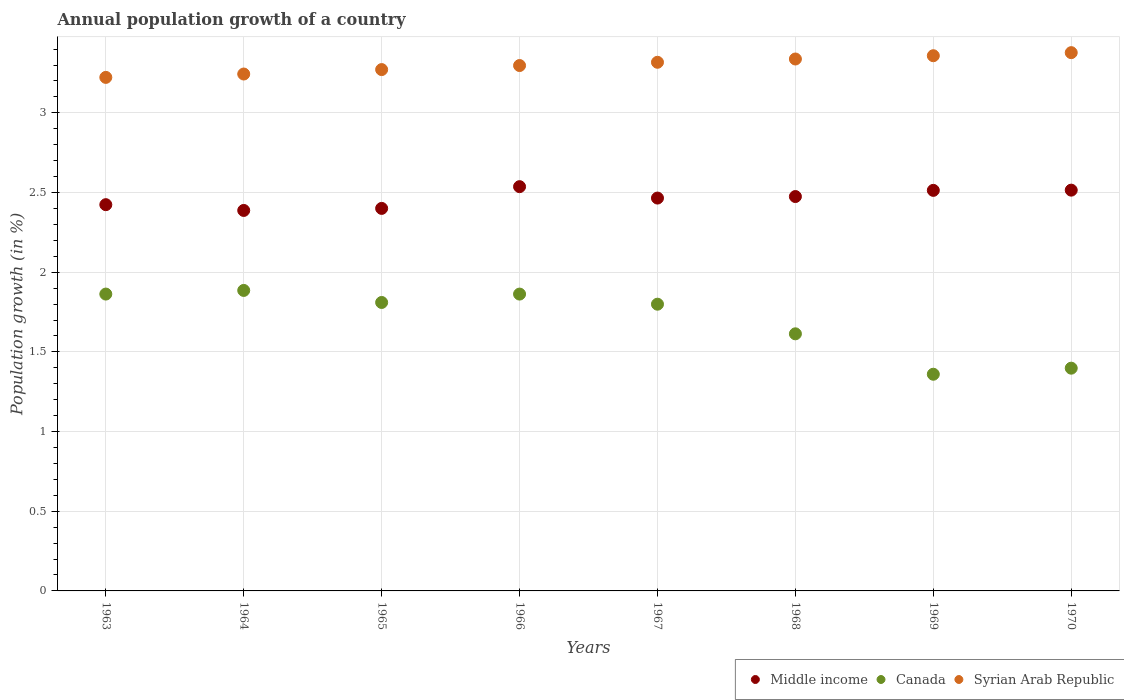How many different coloured dotlines are there?
Give a very brief answer. 3. Is the number of dotlines equal to the number of legend labels?
Offer a very short reply. Yes. What is the annual population growth in Canada in 1966?
Offer a very short reply. 1.86. Across all years, what is the maximum annual population growth in Syrian Arab Republic?
Your response must be concise. 3.38. Across all years, what is the minimum annual population growth in Canada?
Ensure brevity in your answer.  1.36. In which year was the annual population growth in Middle income maximum?
Ensure brevity in your answer.  1966. In which year was the annual population growth in Middle income minimum?
Keep it short and to the point. 1964. What is the total annual population growth in Syrian Arab Republic in the graph?
Ensure brevity in your answer.  26.43. What is the difference between the annual population growth in Middle income in 1964 and that in 1965?
Your answer should be very brief. -0.01. What is the difference between the annual population growth in Syrian Arab Republic in 1967 and the annual population growth in Middle income in 1965?
Provide a short and direct response. 0.92. What is the average annual population growth in Canada per year?
Offer a very short reply. 1.7. In the year 1967, what is the difference between the annual population growth in Canada and annual population growth in Middle income?
Your answer should be very brief. -0.67. In how many years, is the annual population growth in Canada greater than 1.5 %?
Offer a very short reply. 6. What is the ratio of the annual population growth in Middle income in 1968 to that in 1970?
Offer a very short reply. 0.98. Is the difference between the annual population growth in Canada in 1966 and 1968 greater than the difference between the annual population growth in Middle income in 1966 and 1968?
Offer a very short reply. Yes. What is the difference between the highest and the second highest annual population growth in Syrian Arab Republic?
Provide a succinct answer. 0.02. What is the difference between the highest and the lowest annual population growth in Middle income?
Offer a terse response. 0.15. In how many years, is the annual population growth in Canada greater than the average annual population growth in Canada taken over all years?
Provide a succinct answer. 5. Does the annual population growth in Syrian Arab Republic monotonically increase over the years?
Provide a short and direct response. Yes. Is the annual population growth in Middle income strictly less than the annual population growth in Canada over the years?
Make the answer very short. No. How many dotlines are there?
Provide a short and direct response. 3. Are the values on the major ticks of Y-axis written in scientific E-notation?
Your response must be concise. No. Does the graph contain any zero values?
Provide a short and direct response. No. How many legend labels are there?
Your answer should be very brief. 3. How are the legend labels stacked?
Make the answer very short. Horizontal. What is the title of the graph?
Give a very brief answer. Annual population growth of a country. Does "Angola" appear as one of the legend labels in the graph?
Offer a terse response. No. What is the label or title of the Y-axis?
Keep it short and to the point. Population growth (in %). What is the Population growth (in %) of Middle income in 1963?
Offer a terse response. 2.42. What is the Population growth (in %) of Canada in 1963?
Your response must be concise. 1.86. What is the Population growth (in %) in Syrian Arab Republic in 1963?
Offer a very short reply. 3.22. What is the Population growth (in %) of Middle income in 1964?
Keep it short and to the point. 2.39. What is the Population growth (in %) of Canada in 1964?
Offer a very short reply. 1.89. What is the Population growth (in %) in Syrian Arab Republic in 1964?
Offer a very short reply. 3.24. What is the Population growth (in %) in Middle income in 1965?
Make the answer very short. 2.4. What is the Population growth (in %) of Canada in 1965?
Offer a terse response. 1.81. What is the Population growth (in %) in Syrian Arab Republic in 1965?
Provide a succinct answer. 3.27. What is the Population growth (in %) in Middle income in 1966?
Provide a succinct answer. 2.54. What is the Population growth (in %) of Canada in 1966?
Provide a short and direct response. 1.86. What is the Population growth (in %) in Syrian Arab Republic in 1966?
Your answer should be very brief. 3.3. What is the Population growth (in %) of Middle income in 1967?
Provide a short and direct response. 2.47. What is the Population growth (in %) in Canada in 1967?
Give a very brief answer. 1.8. What is the Population growth (in %) in Syrian Arab Republic in 1967?
Your answer should be very brief. 3.32. What is the Population growth (in %) in Middle income in 1968?
Offer a terse response. 2.47. What is the Population growth (in %) of Canada in 1968?
Offer a terse response. 1.61. What is the Population growth (in %) of Syrian Arab Republic in 1968?
Provide a succinct answer. 3.34. What is the Population growth (in %) of Middle income in 1969?
Your answer should be compact. 2.51. What is the Population growth (in %) of Canada in 1969?
Your answer should be very brief. 1.36. What is the Population growth (in %) of Syrian Arab Republic in 1969?
Offer a very short reply. 3.36. What is the Population growth (in %) in Middle income in 1970?
Offer a terse response. 2.52. What is the Population growth (in %) in Canada in 1970?
Keep it short and to the point. 1.4. What is the Population growth (in %) in Syrian Arab Republic in 1970?
Your answer should be very brief. 3.38. Across all years, what is the maximum Population growth (in %) in Middle income?
Your answer should be very brief. 2.54. Across all years, what is the maximum Population growth (in %) of Canada?
Give a very brief answer. 1.89. Across all years, what is the maximum Population growth (in %) in Syrian Arab Republic?
Provide a succinct answer. 3.38. Across all years, what is the minimum Population growth (in %) in Middle income?
Your answer should be very brief. 2.39. Across all years, what is the minimum Population growth (in %) of Canada?
Offer a very short reply. 1.36. Across all years, what is the minimum Population growth (in %) of Syrian Arab Republic?
Your response must be concise. 3.22. What is the total Population growth (in %) in Middle income in the graph?
Your answer should be compact. 19.72. What is the total Population growth (in %) in Canada in the graph?
Offer a very short reply. 13.59. What is the total Population growth (in %) in Syrian Arab Republic in the graph?
Make the answer very short. 26.43. What is the difference between the Population growth (in %) in Middle income in 1963 and that in 1964?
Your answer should be compact. 0.04. What is the difference between the Population growth (in %) in Canada in 1963 and that in 1964?
Keep it short and to the point. -0.02. What is the difference between the Population growth (in %) in Syrian Arab Republic in 1963 and that in 1964?
Provide a short and direct response. -0.02. What is the difference between the Population growth (in %) of Middle income in 1963 and that in 1965?
Keep it short and to the point. 0.02. What is the difference between the Population growth (in %) in Canada in 1963 and that in 1965?
Your response must be concise. 0.05. What is the difference between the Population growth (in %) in Syrian Arab Republic in 1963 and that in 1965?
Your response must be concise. -0.05. What is the difference between the Population growth (in %) in Middle income in 1963 and that in 1966?
Give a very brief answer. -0.11. What is the difference between the Population growth (in %) of Canada in 1963 and that in 1966?
Offer a very short reply. 0. What is the difference between the Population growth (in %) in Syrian Arab Republic in 1963 and that in 1966?
Your answer should be very brief. -0.07. What is the difference between the Population growth (in %) of Middle income in 1963 and that in 1967?
Offer a terse response. -0.04. What is the difference between the Population growth (in %) in Canada in 1963 and that in 1967?
Provide a succinct answer. 0.06. What is the difference between the Population growth (in %) of Syrian Arab Republic in 1963 and that in 1967?
Offer a terse response. -0.09. What is the difference between the Population growth (in %) in Middle income in 1963 and that in 1968?
Your answer should be compact. -0.05. What is the difference between the Population growth (in %) in Canada in 1963 and that in 1968?
Your answer should be compact. 0.25. What is the difference between the Population growth (in %) of Syrian Arab Republic in 1963 and that in 1968?
Offer a terse response. -0.12. What is the difference between the Population growth (in %) in Middle income in 1963 and that in 1969?
Keep it short and to the point. -0.09. What is the difference between the Population growth (in %) of Canada in 1963 and that in 1969?
Your answer should be compact. 0.5. What is the difference between the Population growth (in %) in Syrian Arab Republic in 1963 and that in 1969?
Provide a succinct answer. -0.14. What is the difference between the Population growth (in %) in Middle income in 1963 and that in 1970?
Your answer should be very brief. -0.09. What is the difference between the Population growth (in %) of Canada in 1963 and that in 1970?
Give a very brief answer. 0.47. What is the difference between the Population growth (in %) in Syrian Arab Republic in 1963 and that in 1970?
Ensure brevity in your answer.  -0.16. What is the difference between the Population growth (in %) in Middle income in 1964 and that in 1965?
Offer a very short reply. -0.01. What is the difference between the Population growth (in %) in Canada in 1964 and that in 1965?
Your response must be concise. 0.08. What is the difference between the Population growth (in %) in Syrian Arab Republic in 1964 and that in 1965?
Keep it short and to the point. -0.03. What is the difference between the Population growth (in %) in Middle income in 1964 and that in 1966?
Your answer should be very brief. -0.15. What is the difference between the Population growth (in %) in Canada in 1964 and that in 1966?
Provide a short and direct response. 0.02. What is the difference between the Population growth (in %) of Syrian Arab Republic in 1964 and that in 1966?
Provide a succinct answer. -0.05. What is the difference between the Population growth (in %) of Middle income in 1964 and that in 1967?
Ensure brevity in your answer.  -0.08. What is the difference between the Population growth (in %) in Canada in 1964 and that in 1967?
Provide a short and direct response. 0.09. What is the difference between the Population growth (in %) in Syrian Arab Republic in 1964 and that in 1967?
Offer a terse response. -0.07. What is the difference between the Population growth (in %) in Middle income in 1964 and that in 1968?
Provide a short and direct response. -0.09. What is the difference between the Population growth (in %) in Canada in 1964 and that in 1968?
Keep it short and to the point. 0.27. What is the difference between the Population growth (in %) in Syrian Arab Republic in 1964 and that in 1968?
Give a very brief answer. -0.09. What is the difference between the Population growth (in %) of Middle income in 1964 and that in 1969?
Your answer should be very brief. -0.13. What is the difference between the Population growth (in %) in Canada in 1964 and that in 1969?
Give a very brief answer. 0.53. What is the difference between the Population growth (in %) of Syrian Arab Republic in 1964 and that in 1969?
Your answer should be very brief. -0.11. What is the difference between the Population growth (in %) of Middle income in 1964 and that in 1970?
Your answer should be very brief. -0.13. What is the difference between the Population growth (in %) of Canada in 1964 and that in 1970?
Keep it short and to the point. 0.49. What is the difference between the Population growth (in %) of Syrian Arab Republic in 1964 and that in 1970?
Offer a terse response. -0.13. What is the difference between the Population growth (in %) of Middle income in 1965 and that in 1966?
Your answer should be very brief. -0.14. What is the difference between the Population growth (in %) of Canada in 1965 and that in 1966?
Your response must be concise. -0.05. What is the difference between the Population growth (in %) in Syrian Arab Republic in 1965 and that in 1966?
Your answer should be very brief. -0.03. What is the difference between the Population growth (in %) in Middle income in 1965 and that in 1967?
Your answer should be compact. -0.06. What is the difference between the Population growth (in %) of Canada in 1965 and that in 1967?
Offer a terse response. 0.01. What is the difference between the Population growth (in %) of Syrian Arab Republic in 1965 and that in 1967?
Give a very brief answer. -0.05. What is the difference between the Population growth (in %) of Middle income in 1965 and that in 1968?
Give a very brief answer. -0.07. What is the difference between the Population growth (in %) of Canada in 1965 and that in 1968?
Offer a terse response. 0.2. What is the difference between the Population growth (in %) of Syrian Arab Republic in 1965 and that in 1968?
Make the answer very short. -0.07. What is the difference between the Population growth (in %) of Middle income in 1965 and that in 1969?
Make the answer very short. -0.11. What is the difference between the Population growth (in %) in Canada in 1965 and that in 1969?
Provide a succinct answer. 0.45. What is the difference between the Population growth (in %) of Syrian Arab Republic in 1965 and that in 1969?
Your response must be concise. -0.09. What is the difference between the Population growth (in %) in Middle income in 1965 and that in 1970?
Offer a very short reply. -0.11. What is the difference between the Population growth (in %) in Canada in 1965 and that in 1970?
Your answer should be very brief. 0.41. What is the difference between the Population growth (in %) in Syrian Arab Republic in 1965 and that in 1970?
Ensure brevity in your answer.  -0.11. What is the difference between the Population growth (in %) of Middle income in 1966 and that in 1967?
Your answer should be very brief. 0.07. What is the difference between the Population growth (in %) in Canada in 1966 and that in 1967?
Your response must be concise. 0.06. What is the difference between the Population growth (in %) of Syrian Arab Republic in 1966 and that in 1967?
Keep it short and to the point. -0.02. What is the difference between the Population growth (in %) in Middle income in 1966 and that in 1968?
Your answer should be very brief. 0.06. What is the difference between the Population growth (in %) of Canada in 1966 and that in 1968?
Offer a terse response. 0.25. What is the difference between the Population growth (in %) in Syrian Arab Republic in 1966 and that in 1968?
Give a very brief answer. -0.04. What is the difference between the Population growth (in %) of Middle income in 1966 and that in 1969?
Provide a short and direct response. 0.02. What is the difference between the Population growth (in %) of Canada in 1966 and that in 1969?
Keep it short and to the point. 0.5. What is the difference between the Population growth (in %) in Syrian Arab Republic in 1966 and that in 1969?
Provide a succinct answer. -0.06. What is the difference between the Population growth (in %) of Middle income in 1966 and that in 1970?
Provide a short and direct response. 0.02. What is the difference between the Population growth (in %) in Canada in 1966 and that in 1970?
Give a very brief answer. 0.47. What is the difference between the Population growth (in %) in Syrian Arab Republic in 1966 and that in 1970?
Your answer should be compact. -0.08. What is the difference between the Population growth (in %) in Middle income in 1967 and that in 1968?
Make the answer very short. -0.01. What is the difference between the Population growth (in %) in Canada in 1967 and that in 1968?
Provide a short and direct response. 0.19. What is the difference between the Population growth (in %) in Syrian Arab Republic in 1967 and that in 1968?
Offer a terse response. -0.02. What is the difference between the Population growth (in %) in Middle income in 1967 and that in 1969?
Ensure brevity in your answer.  -0.05. What is the difference between the Population growth (in %) of Canada in 1967 and that in 1969?
Ensure brevity in your answer.  0.44. What is the difference between the Population growth (in %) of Syrian Arab Republic in 1967 and that in 1969?
Keep it short and to the point. -0.04. What is the difference between the Population growth (in %) of Middle income in 1967 and that in 1970?
Ensure brevity in your answer.  -0.05. What is the difference between the Population growth (in %) in Canada in 1967 and that in 1970?
Provide a short and direct response. 0.4. What is the difference between the Population growth (in %) in Syrian Arab Republic in 1967 and that in 1970?
Your answer should be very brief. -0.06. What is the difference between the Population growth (in %) in Middle income in 1968 and that in 1969?
Provide a short and direct response. -0.04. What is the difference between the Population growth (in %) of Canada in 1968 and that in 1969?
Ensure brevity in your answer.  0.25. What is the difference between the Population growth (in %) of Syrian Arab Republic in 1968 and that in 1969?
Your response must be concise. -0.02. What is the difference between the Population growth (in %) in Middle income in 1968 and that in 1970?
Give a very brief answer. -0.04. What is the difference between the Population growth (in %) in Canada in 1968 and that in 1970?
Provide a succinct answer. 0.22. What is the difference between the Population growth (in %) in Syrian Arab Republic in 1968 and that in 1970?
Offer a very short reply. -0.04. What is the difference between the Population growth (in %) of Middle income in 1969 and that in 1970?
Ensure brevity in your answer.  -0. What is the difference between the Population growth (in %) in Canada in 1969 and that in 1970?
Offer a very short reply. -0.04. What is the difference between the Population growth (in %) of Syrian Arab Republic in 1969 and that in 1970?
Give a very brief answer. -0.02. What is the difference between the Population growth (in %) of Middle income in 1963 and the Population growth (in %) of Canada in 1964?
Ensure brevity in your answer.  0.54. What is the difference between the Population growth (in %) in Middle income in 1963 and the Population growth (in %) in Syrian Arab Republic in 1964?
Provide a succinct answer. -0.82. What is the difference between the Population growth (in %) in Canada in 1963 and the Population growth (in %) in Syrian Arab Republic in 1964?
Make the answer very short. -1.38. What is the difference between the Population growth (in %) in Middle income in 1963 and the Population growth (in %) in Canada in 1965?
Your answer should be very brief. 0.61. What is the difference between the Population growth (in %) in Middle income in 1963 and the Population growth (in %) in Syrian Arab Republic in 1965?
Keep it short and to the point. -0.85. What is the difference between the Population growth (in %) of Canada in 1963 and the Population growth (in %) of Syrian Arab Republic in 1965?
Offer a terse response. -1.41. What is the difference between the Population growth (in %) in Middle income in 1963 and the Population growth (in %) in Canada in 1966?
Your response must be concise. 0.56. What is the difference between the Population growth (in %) in Middle income in 1963 and the Population growth (in %) in Syrian Arab Republic in 1966?
Your answer should be compact. -0.87. What is the difference between the Population growth (in %) of Canada in 1963 and the Population growth (in %) of Syrian Arab Republic in 1966?
Provide a short and direct response. -1.43. What is the difference between the Population growth (in %) in Middle income in 1963 and the Population growth (in %) in Canada in 1967?
Your answer should be very brief. 0.62. What is the difference between the Population growth (in %) in Middle income in 1963 and the Population growth (in %) in Syrian Arab Republic in 1967?
Offer a terse response. -0.89. What is the difference between the Population growth (in %) of Canada in 1963 and the Population growth (in %) of Syrian Arab Republic in 1967?
Provide a short and direct response. -1.45. What is the difference between the Population growth (in %) in Middle income in 1963 and the Population growth (in %) in Canada in 1968?
Give a very brief answer. 0.81. What is the difference between the Population growth (in %) of Middle income in 1963 and the Population growth (in %) of Syrian Arab Republic in 1968?
Offer a terse response. -0.91. What is the difference between the Population growth (in %) of Canada in 1963 and the Population growth (in %) of Syrian Arab Republic in 1968?
Provide a succinct answer. -1.48. What is the difference between the Population growth (in %) of Middle income in 1963 and the Population growth (in %) of Canada in 1969?
Your answer should be very brief. 1.06. What is the difference between the Population growth (in %) of Middle income in 1963 and the Population growth (in %) of Syrian Arab Republic in 1969?
Your answer should be very brief. -0.93. What is the difference between the Population growth (in %) of Canada in 1963 and the Population growth (in %) of Syrian Arab Republic in 1969?
Make the answer very short. -1.5. What is the difference between the Population growth (in %) in Middle income in 1963 and the Population growth (in %) in Canada in 1970?
Your response must be concise. 1.03. What is the difference between the Population growth (in %) in Middle income in 1963 and the Population growth (in %) in Syrian Arab Republic in 1970?
Keep it short and to the point. -0.95. What is the difference between the Population growth (in %) in Canada in 1963 and the Population growth (in %) in Syrian Arab Republic in 1970?
Keep it short and to the point. -1.51. What is the difference between the Population growth (in %) in Middle income in 1964 and the Population growth (in %) in Canada in 1965?
Your response must be concise. 0.58. What is the difference between the Population growth (in %) in Middle income in 1964 and the Population growth (in %) in Syrian Arab Republic in 1965?
Offer a very short reply. -0.88. What is the difference between the Population growth (in %) in Canada in 1964 and the Population growth (in %) in Syrian Arab Republic in 1965?
Offer a very short reply. -1.39. What is the difference between the Population growth (in %) in Middle income in 1964 and the Population growth (in %) in Canada in 1966?
Provide a succinct answer. 0.52. What is the difference between the Population growth (in %) in Middle income in 1964 and the Population growth (in %) in Syrian Arab Republic in 1966?
Your answer should be compact. -0.91. What is the difference between the Population growth (in %) of Canada in 1964 and the Population growth (in %) of Syrian Arab Republic in 1966?
Offer a terse response. -1.41. What is the difference between the Population growth (in %) in Middle income in 1964 and the Population growth (in %) in Canada in 1967?
Keep it short and to the point. 0.59. What is the difference between the Population growth (in %) in Middle income in 1964 and the Population growth (in %) in Syrian Arab Republic in 1967?
Keep it short and to the point. -0.93. What is the difference between the Population growth (in %) in Canada in 1964 and the Population growth (in %) in Syrian Arab Republic in 1967?
Provide a short and direct response. -1.43. What is the difference between the Population growth (in %) in Middle income in 1964 and the Population growth (in %) in Canada in 1968?
Ensure brevity in your answer.  0.77. What is the difference between the Population growth (in %) in Middle income in 1964 and the Population growth (in %) in Syrian Arab Republic in 1968?
Make the answer very short. -0.95. What is the difference between the Population growth (in %) of Canada in 1964 and the Population growth (in %) of Syrian Arab Republic in 1968?
Provide a short and direct response. -1.45. What is the difference between the Population growth (in %) of Middle income in 1964 and the Population growth (in %) of Canada in 1969?
Offer a very short reply. 1.03. What is the difference between the Population growth (in %) of Middle income in 1964 and the Population growth (in %) of Syrian Arab Republic in 1969?
Your answer should be compact. -0.97. What is the difference between the Population growth (in %) in Canada in 1964 and the Population growth (in %) in Syrian Arab Republic in 1969?
Your answer should be compact. -1.47. What is the difference between the Population growth (in %) of Middle income in 1964 and the Population growth (in %) of Canada in 1970?
Your answer should be compact. 0.99. What is the difference between the Population growth (in %) of Middle income in 1964 and the Population growth (in %) of Syrian Arab Republic in 1970?
Offer a very short reply. -0.99. What is the difference between the Population growth (in %) of Canada in 1964 and the Population growth (in %) of Syrian Arab Republic in 1970?
Ensure brevity in your answer.  -1.49. What is the difference between the Population growth (in %) in Middle income in 1965 and the Population growth (in %) in Canada in 1966?
Offer a terse response. 0.54. What is the difference between the Population growth (in %) in Middle income in 1965 and the Population growth (in %) in Syrian Arab Republic in 1966?
Your response must be concise. -0.9. What is the difference between the Population growth (in %) in Canada in 1965 and the Population growth (in %) in Syrian Arab Republic in 1966?
Ensure brevity in your answer.  -1.49. What is the difference between the Population growth (in %) in Middle income in 1965 and the Population growth (in %) in Canada in 1967?
Provide a succinct answer. 0.6. What is the difference between the Population growth (in %) of Middle income in 1965 and the Population growth (in %) of Syrian Arab Republic in 1967?
Ensure brevity in your answer.  -0.92. What is the difference between the Population growth (in %) in Canada in 1965 and the Population growth (in %) in Syrian Arab Republic in 1967?
Your answer should be very brief. -1.51. What is the difference between the Population growth (in %) of Middle income in 1965 and the Population growth (in %) of Canada in 1968?
Your answer should be very brief. 0.79. What is the difference between the Population growth (in %) of Middle income in 1965 and the Population growth (in %) of Syrian Arab Republic in 1968?
Give a very brief answer. -0.94. What is the difference between the Population growth (in %) of Canada in 1965 and the Population growth (in %) of Syrian Arab Republic in 1968?
Your answer should be compact. -1.53. What is the difference between the Population growth (in %) of Middle income in 1965 and the Population growth (in %) of Canada in 1969?
Ensure brevity in your answer.  1.04. What is the difference between the Population growth (in %) of Middle income in 1965 and the Population growth (in %) of Syrian Arab Republic in 1969?
Keep it short and to the point. -0.96. What is the difference between the Population growth (in %) of Canada in 1965 and the Population growth (in %) of Syrian Arab Republic in 1969?
Ensure brevity in your answer.  -1.55. What is the difference between the Population growth (in %) of Middle income in 1965 and the Population growth (in %) of Canada in 1970?
Offer a terse response. 1. What is the difference between the Population growth (in %) of Middle income in 1965 and the Population growth (in %) of Syrian Arab Republic in 1970?
Your answer should be very brief. -0.98. What is the difference between the Population growth (in %) of Canada in 1965 and the Population growth (in %) of Syrian Arab Republic in 1970?
Provide a short and direct response. -1.57. What is the difference between the Population growth (in %) in Middle income in 1966 and the Population growth (in %) in Canada in 1967?
Your response must be concise. 0.74. What is the difference between the Population growth (in %) of Middle income in 1966 and the Population growth (in %) of Syrian Arab Republic in 1967?
Keep it short and to the point. -0.78. What is the difference between the Population growth (in %) of Canada in 1966 and the Population growth (in %) of Syrian Arab Republic in 1967?
Provide a succinct answer. -1.45. What is the difference between the Population growth (in %) in Middle income in 1966 and the Population growth (in %) in Canada in 1968?
Ensure brevity in your answer.  0.92. What is the difference between the Population growth (in %) of Middle income in 1966 and the Population growth (in %) of Syrian Arab Republic in 1968?
Offer a very short reply. -0.8. What is the difference between the Population growth (in %) in Canada in 1966 and the Population growth (in %) in Syrian Arab Republic in 1968?
Your answer should be compact. -1.48. What is the difference between the Population growth (in %) of Middle income in 1966 and the Population growth (in %) of Canada in 1969?
Your response must be concise. 1.18. What is the difference between the Population growth (in %) of Middle income in 1966 and the Population growth (in %) of Syrian Arab Republic in 1969?
Your answer should be compact. -0.82. What is the difference between the Population growth (in %) of Canada in 1966 and the Population growth (in %) of Syrian Arab Republic in 1969?
Your response must be concise. -1.5. What is the difference between the Population growth (in %) in Middle income in 1966 and the Population growth (in %) in Canada in 1970?
Your response must be concise. 1.14. What is the difference between the Population growth (in %) of Middle income in 1966 and the Population growth (in %) of Syrian Arab Republic in 1970?
Your answer should be compact. -0.84. What is the difference between the Population growth (in %) in Canada in 1966 and the Population growth (in %) in Syrian Arab Republic in 1970?
Your answer should be very brief. -1.52. What is the difference between the Population growth (in %) of Middle income in 1967 and the Population growth (in %) of Canada in 1968?
Keep it short and to the point. 0.85. What is the difference between the Population growth (in %) in Middle income in 1967 and the Population growth (in %) in Syrian Arab Republic in 1968?
Give a very brief answer. -0.87. What is the difference between the Population growth (in %) in Canada in 1967 and the Population growth (in %) in Syrian Arab Republic in 1968?
Offer a terse response. -1.54. What is the difference between the Population growth (in %) in Middle income in 1967 and the Population growth (in %) in Canada in 1969?
Make the answer very short. 1.11. What is the difference between the Population growth (in %) in Middle income in 1967 and the Population growth (in %) in Syrian Arab Republic in 1969?
Offer a very short reply. -0.89. What is the difference between the Population growth (in %) of Canada in 1967 and the Population growth (in %) of Syrian Arab Republic in 1969?
Your answer should be compact. -1.56. What is the difference between the Population growth (in %) in Middle income in 1967 and the Population growth (in %) in Canada in 1970?
Ensure brevity in your answer.  1.07. What is the difference between the Population growth (in %) in Middle income in 1967 and the Population growth (in %) in Syrian Arab Republic in 1970?
Your answer should be compact. -0.91. What is the difference between the Population growth (in %) in Canada in 1967 and the Population growth (in %) in Syrian Arab Republic in 1970?
Keep it short and to the point. -1.58. What is the difference between the Population growth (in %) in Middle income in 1968 and the Population growth (in %) in Canada in 1969?
Your answer should be very brief. 1.12. What is the difference between the Population growth (in %) of Middle income in 1968 and the Population growth (in %) of Syrian Arab Republic in 1969?
Offer a very short reply. -0.88. What is the difference between the Population growth (in %) in Canada in 1968 and the Population growth (in %) in Syrian Arab Republic in 1969?
Offer a terse response. -1.75. What is the difference between the Population growth (in %) in Middle income in 1968 and the Population growth (in %) in Canada in 1970?
Keep it short and to the point. 1.08. What is the difference between the Population growth (in %) in Middle income in 1968 and the Population growth (in %) in Syrian Arab Republic in 1970?
Keep it short and to the point. -0.9. What is the difference between the Population growth (in %) of Canada in 1968 and the Population growth (in %) of Syrian Arab Republic in 1970?
Your answer should be compact. -1.76. What is the difference between the Population growth (in %) of Middle income in 1969 and the Population growth (in %) of Canada in 1970?
Provide a succinct answer. 1.12. What is the difference between the Population growth (in %) of Middle income in 1969 and the Population growth (in %) of Syrian Arab Republic in 1970?
Give a very brief answer. -0.86. What is the difference between the Population growth (in %) of Canada in 1969 and the Population growth (in %) of Syrian Arab Republic in 1970?
Keep it short and to the point. -2.02. What is the average Population growth (in %) of Middle income per year?
Your response must be concise. 2.46. What is the average Population growth (in %) of Canada per year?
Your answer should be compact. 1.7. What is the average Population growth (in %) in Syrian Arab Republic per year?
Keep it short and to the point. 3.3. In the year 1963, what is the difference between the Population growth (in %) in Middle income and Population growth (in %) in Canada?
Ensure brevity in your answer.  0.56. In the year 1963, what is the difference between the Population growth (in %) of Middle income and Population growth (in %) of Syrian Arab Republic?
Offer a very short reply. -0.8. In the year 1963, what is the difference between the Population growth (in %) in Canada and Population growth (in %) in Syrian Arab Republic?
Your answer should be compact. -1.36. In the year 1964, what is the difference between the Population growth (in %) of Middle income and Population growth (in %) of Canada?
Make the answer very short. 0.5. In the year 1964, what is the difference between the Population growth (in %) of Middle income and Population growth (in %) of Syrian Arab Republic?
Ensure brevity in your answer.  -0.86. In the year 1964, what is the difference between the Population growth (in %) in Canada and Population growth (in %) in Syrian Arab Republic?
Keep it short and to the point. -1.36. In the year 1965, what is the difference between the Population growth (in %) in Middle income and Population growth (in %) in Canada?
Your answer should be very brief. 0.59. In the year 1965, what is the difference between the Population growth (in %) of Middle income and Population growth (in %) of Syrian Arab Republic?
Keep it short and to the point. -0.87. In the year 1965, what is the difference between the Population growth (in %) of Canada and Population growth (in %) of Syrian Arab Republic?
Ensure brevity in your answer.  -1.46. In the year 1966, what is the difference between the Population growth (in %) of Middle income and Population growth (in %) of Canada?
Provide a succinct answer. 0.67. In the year 1966, what is the difference between the Population growth (in %) in Middle income and Population growth (in %) in Syrian Arab Republic?
Provide a short and direct response. -0.76. In the year 1966, what is the difference between the Population growth (in %) of Canada and Population growth (in %) of Syrian Arab Republic?
Your response must be concise. -1.43. In the year 1967, what is the difference between the Population growth (in %) of Middle income and Population growth (in %) of Canada?
Your answer should be very brief. 0.67. In the year 1967, what is the difference between the Population growth (in %) of Middle income and Population growth (in %) of Syrian Arab Republic?
Offer a terse response. -0.85. In the year 1967, what is the difference between the Population growth (in %) in Canada and Population growth (in %) in Syrian Arab Republic?
Offer a terse response. -1.52. In the year 1968, what is the difference between the Population growth (in %) in Middle income and Population growth (in %) in Canada?
Your answer should be compact. 0.86. In the year 1968, what is the difference between the Population growth (in %) in Middle income and Population growth (in %) in Syrian Arab Republic?
Offer a very short reply. -0.86. In the year 1968, what is the difference between the Population growth (in %) in Canada and Population growth (in %) in Syrian Arab Republic?
Offer a very short reply. -1.72. In the year 1969, what is the difference between the Population growth (in %) in Middle income and Population growth (in %) in Canada?
Keep it short and to the point. 1.15. In the year 1969, what is the difference between the Population growth (in %) in Middle income and Population growth (in %) in Syrian Arab Republic?
Your response must be concise. -0.84. In the year 1969, what is the difference between the Population growth (in %) in Canada and Population growth (in %) in Syrian Arab Republic?
Offer a very short reply. -2. In the year 1970, what is the difference between the Population growth (in %) of Middle income and Population growth (in %) of Canada?
Your answer should be compact. 1.12. In the year 1970, what is the difference between the Population growth (in %) of Middle income and Population growth (in %) of Syrian Arab Republic?
Make the answer very short. -0.86. In the year 1970, what is the difference between the Population growth (in %) of Canada and Population growth (in %) of Syrian Arab Republic?
Give a very brief answer. -1.98. What is the ratio of the Population growth (in %) in Middle income in 1963 to that in 1964?
Make the answer very short. 1.02. What is the ratio of the Population growth (in %) in Canada in 1963 to that in 1964?
Keep it short and to the point. 0.99. What is the ratio of the Population growth (in %) in Middle income in 1963 to that in 1965?
Make the answer very short. 1.01. What is the ratio of the Population growth (in %) of Canada in 1963 to that in 1965?
Ensure brevity in your answer.  1.03. What is the ratio of the Population growth (in %) in Middle income in 1963 to that in 1966?
Ensure brevity in your answer.  0.96. What is the ratio of the Population growth (in %) in Canada in 1963 to that in 1966?
Ensure brevity in your answer.  1. What is the ratio of the Population growth (in %) of Syrian Arab Republic in 1963 to that in 1966?
Offer a very short reply. 0.98. What is the ratio of the Population growth (in %) in Middle income in 1963 to that in 1967?
Keep it short and to the point. 0.98. What is the ratio of the Population growth (in %) in Canada in 1963 to that in 1967?
Offer a very short reply. 1.04. What is the ratio of the Population growth (in %) of Syrian Arab Republic in 1963 to that in 1967?
Offer a very short reply. 0.97. What is the ratio of the Population growth (in %) of Middle income in 1963 to that in 1968?
Your response must be concise. 0.98. What is the ratio of the Population growth (in %) in Canada in 1963 to that in 1968?
Make the answer very short. 1.15. What is the ratio of the Population growth (in %) of Syrian Arab Republic in 1963 to that in 1968?
Keep it short and to the point. 0.97. What is the ratio of the Population growth (in %) of Canada in 1963 to that in 1969?
Your response must be concise. 1.37. What is the ratio of the Population growth (in %) in Syrian Arab Republic in 1963 to that in 1969?
Your answer should be compact. 0.96. What is the ratio of the Population growth (in %) in Middle income in 1963 to that in 1970?
Give a very brief answer. 0.96. What is the ratio of the Population growth (in %) in Canada in 1963 to that in 1970?
Offer a terse response. 1.33. What is the ratio of the Population growth (in %) in Syrian Arab Republic in 1963 to that in 1970?
Provide a succinct answer. 0.95. What is the ratio of the Population growth (in %) of Middle income in 1964 to that in 1965?
Provide a succinct answer. 0.99. What is the ratio of the Population growth (in %) of Canada in 1964 to that in 1965?
Make the answer very short. 1.04. What is the ratio of the Population growth (in %) of Middle income in 1964 to that in 1966?
Offer a terse response. 0.94. What is the ratio of the Population growth (in %) of Canada in 1964 to that in 1966?
Keep it short and to the point. 1.01. What is the ratio of the Population growth (in %) of Syrian Arab Republic in 1964 to that in 1966?
Offer a terse response. 0.98. What is the ratio of the Population growth (in %) of Middle income in 1964 to that in 1967?
Ensure brevity in your answer.  0.97. What is the ratio of the Population growth (in %) of Canada in 1964 to that in 1967?
Provide a succinct answer. 1.05. What is the ratio of the Population growth (in %) of Syrian Arab Republic in 1964 to that in 1967?
Your answer should be very brief. 0.98. What is the ratio of the Population growth (in %) of Middle income in 1964 to that in 1968?
Give a very brief answer. 0.96. What is the ratio of the Population growth (in %) in Canada in 1964 to that in 1968?
Ensure brevity in your answer.  1.17. What is the ratio of the Population growth (in %) of Syrian Arab Republic in 1964 to that in 1968?
Give a very brief answer. 0.97. What is the ratio of the Population growth (in %) in Middle income in 1964 to that in 1969?
Provide a short and direct response. 0.95. What is the ratio of the Population growth (in %) of Canada in 1964 to that in 1969?
Your response must be concise. 1.39. What is the ratio of the Population growth (in %) in Syrian Arab Republic in 1964 to that in 1969?
Give a very brief answer. 0.97. What is the ratio of the Population growth (in %) in Middle income in 1964 to that in 1970?
Keep it short and to the point. 0.95. What is the ratio of the Population growth (in %) of Canada in 1964 to that in 1970?
Ensure brevity in your answer.  1.35. What is the ratio of the Population growth (in %) of Syrian Arab Republic in 1964 to that in 1970?
Offer a terse response. 0.96. What is the ratio of the Population growth (in %) of Middle income in 1965 to that in 1966?
Offer a very short reply. 0.95. What is the ratio of the Population growth (in %) in Canada in 1965 to that in 1966?
Your response must be concise. 0.97. What is the ratio of the Population growth (in %) of Syrian Arab Republic in 1965 to that in 1966?
Your answer should be compact. 0.99. What is the ratio of the Population growth (in %) of Middle income in 1965 to that in 1967?
Your answer should be compact. 0.97. What is the ratio of the Population growth (in %) of Syrian Arab Republic in 1965 to that in 1967?
Provide a short and direct response. 0.99. What is the ratio of the Population growth (in %) in Middle income in 1965 to that in 1968?
Ensure brevity in your answer.  0.97. What is the ratio of the Population growth (in %) in Canada in 1965 to that in 1968?
Your response must be concise. 1.12. What is the ratio of the Population growth (in %) in Syrian Arab Republic in 1965 to that in 1968?
Your answer should be very brief. 0.98. What is the ratio of the Population growth (in %) in Middle income in 1965 to that in 1969?
Offer a terse response. 0.95. What is the ratio of the Population growth (in %) in Canada in 1965 to that in 1969?
Keep it short and to the point. 1.33. What is the ratio of the Population growth (in %) in Syrian Arab Republic in 1965 to that in 1969?
Your answer should be very brief. 0.97. What is the ratio of the Population growth (in %) of Middle income in 1965 to that in 1970?
Ensure brevity in your answer.  0.95. What is the ratio of the Population growth (in %) in Canada in 1965 to that in 1970?
Make the answer very short. 1.29. What is the ratio of the Population growth (in %) in Syrian Arab Republic in 1965 to that in 1970?
Give a very brief answer. 0.97. What is the ratio of the Population growth (in %) of Canada in 1966 to that in 1967?
Ensure brevity in your answer.  1.04. What is the ratio of the Population growth (in %) of Syrian Arab Republic in 1966 to that in 1967?
Your answer should be compact. 0.99. What is the ratio of the Population growth (in %) in Middle income in 1966 to that in 1968?
Give a very brief answer. 1.03. What is the ratio of the Population growth (in %) of Canada in 1966 to that in 1968?
Offer a terse response. 1.15. What is the ratio of the Population growth (in %) of Middle income in 1966 to that in 1969?
Your response must be concise. 1.01. What is the ratio of the Population growth (in %) in Canada in 1966 to that in 1969?
Give a very brief answer. 1.37. What is the ratio of the Population growth (in %) of Syrian Arab Republic in 1966 to that in 1969?
Ensure brevity in your answer.  0.98. What is the ratio of the Population growth (in %) in Middle income in 1966 to that in 1970?
Make the answer very short. 1.01. What is the ratio of the Population growth (in %) in Canada in 1966 to that in 1970?
Your response must be concise. 1.33. What is the ratio of the Population growth (in %) in Syrian Arab Republic in 1966 to that in 1970?
Give a very brief answer. 0.98. What is the ratio of the Population growth (in %) in Canada in 1967 to that in 1968?
Provide a succinct answer. 1.12. What is the ratio of the Population growth (in %) of Middle income in 1967 to that in 1969?
Offer a terse response. 0.98. What is the ratio of the Population growth (in %) of Canada in 1967 to that in 1969?
Your answer should be very brief. 1.32. What is the ratio of the Population growth (in %) in Middle income in 1967 to that in 1970?
Provide a succinct answer. 0.98. What is the ratio of the Population growth (in %) in Canada in 1967 to that in 1970?
Ensure brevity in your answer.  1.29. What is the ratio of the Population growth (in %) in Syrian Arab Republic in 1967 to that in 1970?
Keep it short and to the point. 0.98. What is the ratio of the Population growth (in %) in Middle income in 1968 to that in 1969?
Give a very brief answer. 0.98. What is the ratio of the Population growth (in %) of Canada in 1968 to that in 1969?
Your answer should be very brief. 1.19. What is the ratio of the Population growth (in %) in Canada in 1968 to that in 1970?
Provide a short and direct response. 1.15. What is the ratio of the Population growth (in %) of Middle income in 1969 to that in 1970?
Offer a terse response. 1. What is the ratio of the Population growth (in %) of Canada in 1969 to that in 1970?
Keep it short and to the point. 0.97. What is the ratio of the Population growth (in %) in Syrian Arab Republic in 1969 to that in 1970?
Offer a terse response. 0.99. What is the difference between the highest and the second highest Population growth (in %) of Middle income?
Keep it short and to the point. 0.02. What is the difference between the highest and the second highest Population growth (in %) in Canada?
Make the answer very short. 0.02. What is the difference between the highest and the second highest Population growth (in %) in Syrian Arab Republic?
Make the answer very short. 0.02. What is the difference between the highest and the lowest Population growth (in %) in Middle income?
Offer a very short reply. 0.15. What is the difference between the highest and the lowest Population growth (in %) in Canada?
Provide a short and direct response. 0.53. What is the difference between the highest and the lowest Population growth (in %) of Syrian Arab Republic?
Ensure brevity in your answer.  0.16. 